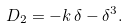<formula> <loc_0><loc_0><loc_500><loc_500>D _ { 2 } = - k \, \delta - \delta ^ { 3 } .</formula> 